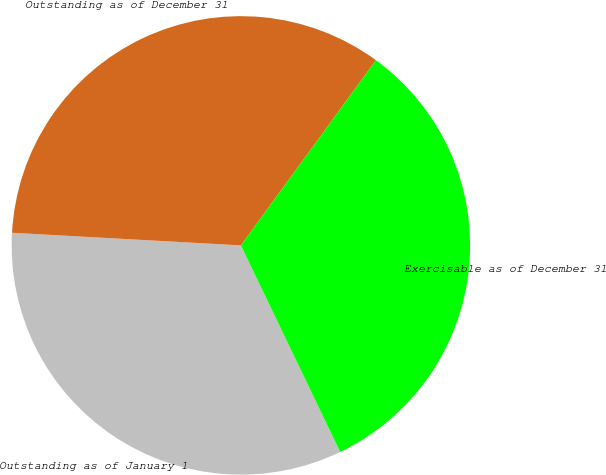Convert chart. <chart><loc_0><loc_0><loc_500><loc_500><pie_chart><fcel>Outstanding as of January 1<fcel>Outstanding as of December 31<fcel>Exercisable as of December 31<nl><fcel>33.01%<fcel>34.15%<fcel>32.84%<nl></chart> 